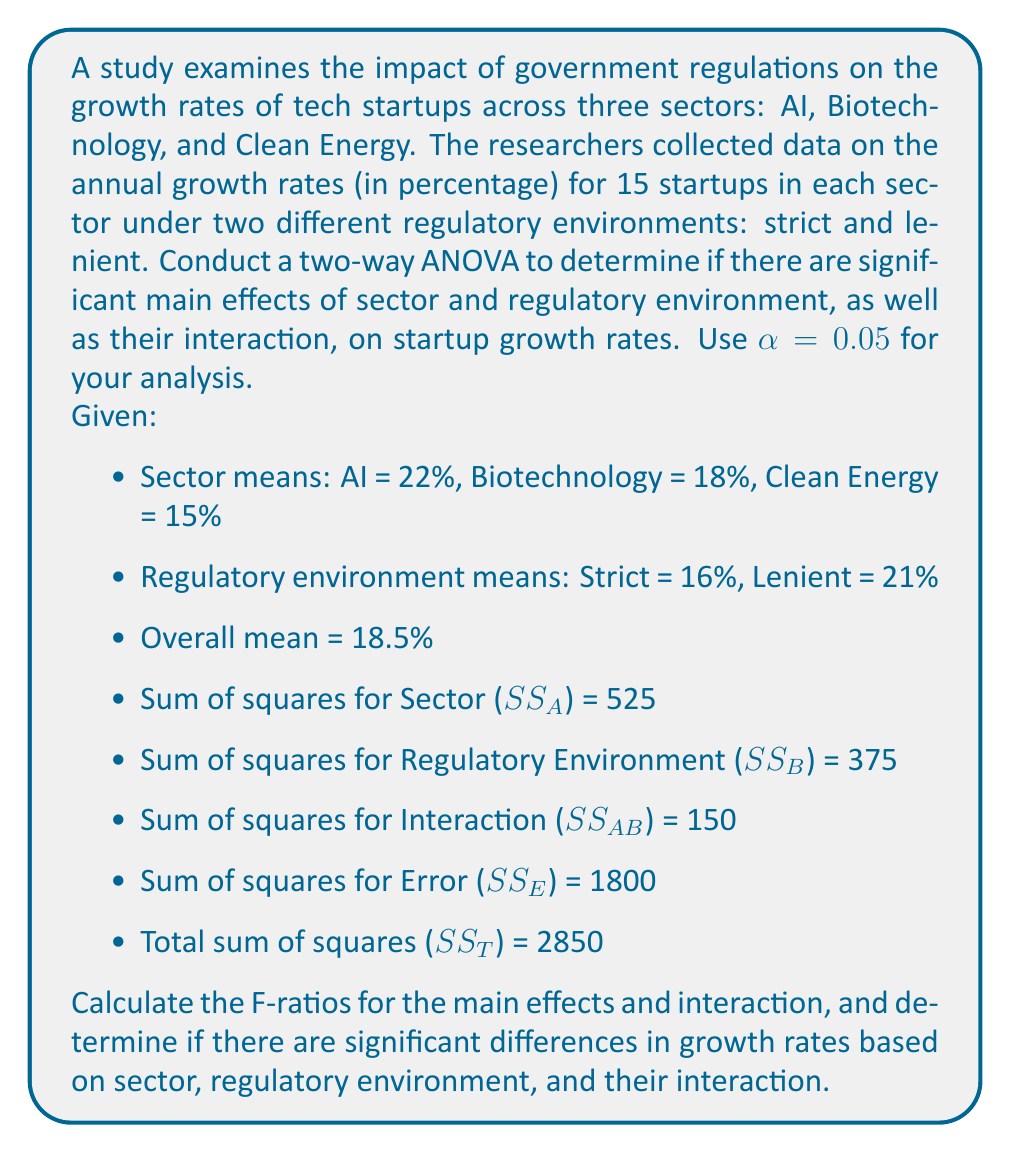Solve this math problem. To conduct a two-way ANOVA, we need to calculate the F-ratios for the main effects (Sector and Regulatory Environment) and their interaction. We'll follow these steps:

1. Calculate degrees of freedom (df):
   - Sector (A): df_A = 3 - 1 = 2
   - Regulatory Environment (B): df_B = 2 - 1 = 1
   - Interaction (AB): df_AB = df_A × df_B = 2 × 1 = 2
   - Error (E): df_E = 3 × 2 × (15 - 1) = 84
   - Total: df_T = (3 × 2 × 15) - 1 = 89

2. Calculate Mean Squares (MS):
   $$ MS_A = \frac{SS_A}{df_A} = \frac{525}{2} = 262.5 $$
   $$ MS_B = \frac{SS_B}{df_B} = \frac{375}{1} = 375 $$
   $$ MS_{AB} = \frac{SS_{AB}}{df_{AB}} = \frac{150}{2} = 75 $$
   $$ MS_E = \frac{SS_E}{df_E} = \frac{1800}{84} = 21.43 $$

3. Calculate F-ratios:
   $$ F_A = \frac{MS_A}{MS_E} = \frac{262.5}{21.43} = 12.25 $$
   $$ F_B = \frac{MS_B}{MS_E} = \frac{375}{21.43} = 17.50 $$
   $$ F_{AB} = \frac{MS_{AB}}{MS_E} = \frac{75}{21.43} = 3.50 $$

4. Determine critical F-values:
   - For Sector: F_crit(2, 84) ≈ 3.11
   - For Regulatory Environment: F_crit(1, 84) ≈ 3.96
   - For Interaction: F_crit(2, 84) ≈ 3.11

5. Compare F-ratios to critical F-values:
   - Sector: 12.25 > 3.11, so there is a significant main effect of sector
   - Regulatory Environment: 17.50 > 3.96, so there is a significant main effect of regulatory environment
   - Interaction: 3.50 > 3.11, so there is a significant interaction effect

6. Calculate effect sizes (partial η²):
   $$ \text{Partial } \eta^2_A = \frac{SS_A}{SS_A + SS_E} = \frac{525}{525 + 1800} = 0.226 $$
   $$ \text{Partial } \eta^2_B = \frac{SS_B}{SS_B + SS_E} = \frac{375}{375 + 1800} = 0.172 $$
   $$ \text{Partial } \eta^2_{AB} = \frac{SS_{AB}}{SS_{AB} + SS_E} = \frac{150}{150 + 1800} = 0.077 $$
Answer: The two-way ANOVA reveals significant main effects for both sector (F(2, 84) = 12.25, p < 0.05, partial η² = 0.226) and regulatory environment (F(1, 84) = 17.50, p < 0.05, partial η² = 0.172) on tech startup growth rates. Additionally, there is a significant interaction effect between sector and regulatory environment (F(2, 84) = 3.50, p < 0.05, partial η² = 0.077). These results suggest that both the sector in which a tech startup operates and the regulatory environment have significant influences on growth rates, with their combined effect also playing a role in determining startup performance. 